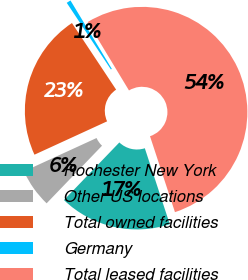Convert chart to OTSL. <chart><loc_0><loc_0><loc_500><loc_500><pie_chart><fcel>Rochester New York<fcel>Other US locations<fcel>Total owned facilities<fcel>Germany<fcel>Total leased facilities<nl><fcel>17.24%<fcel>5.96%<fcel>22.53%<fcel>0.67%<fcel>53.59%<nl></chart> 